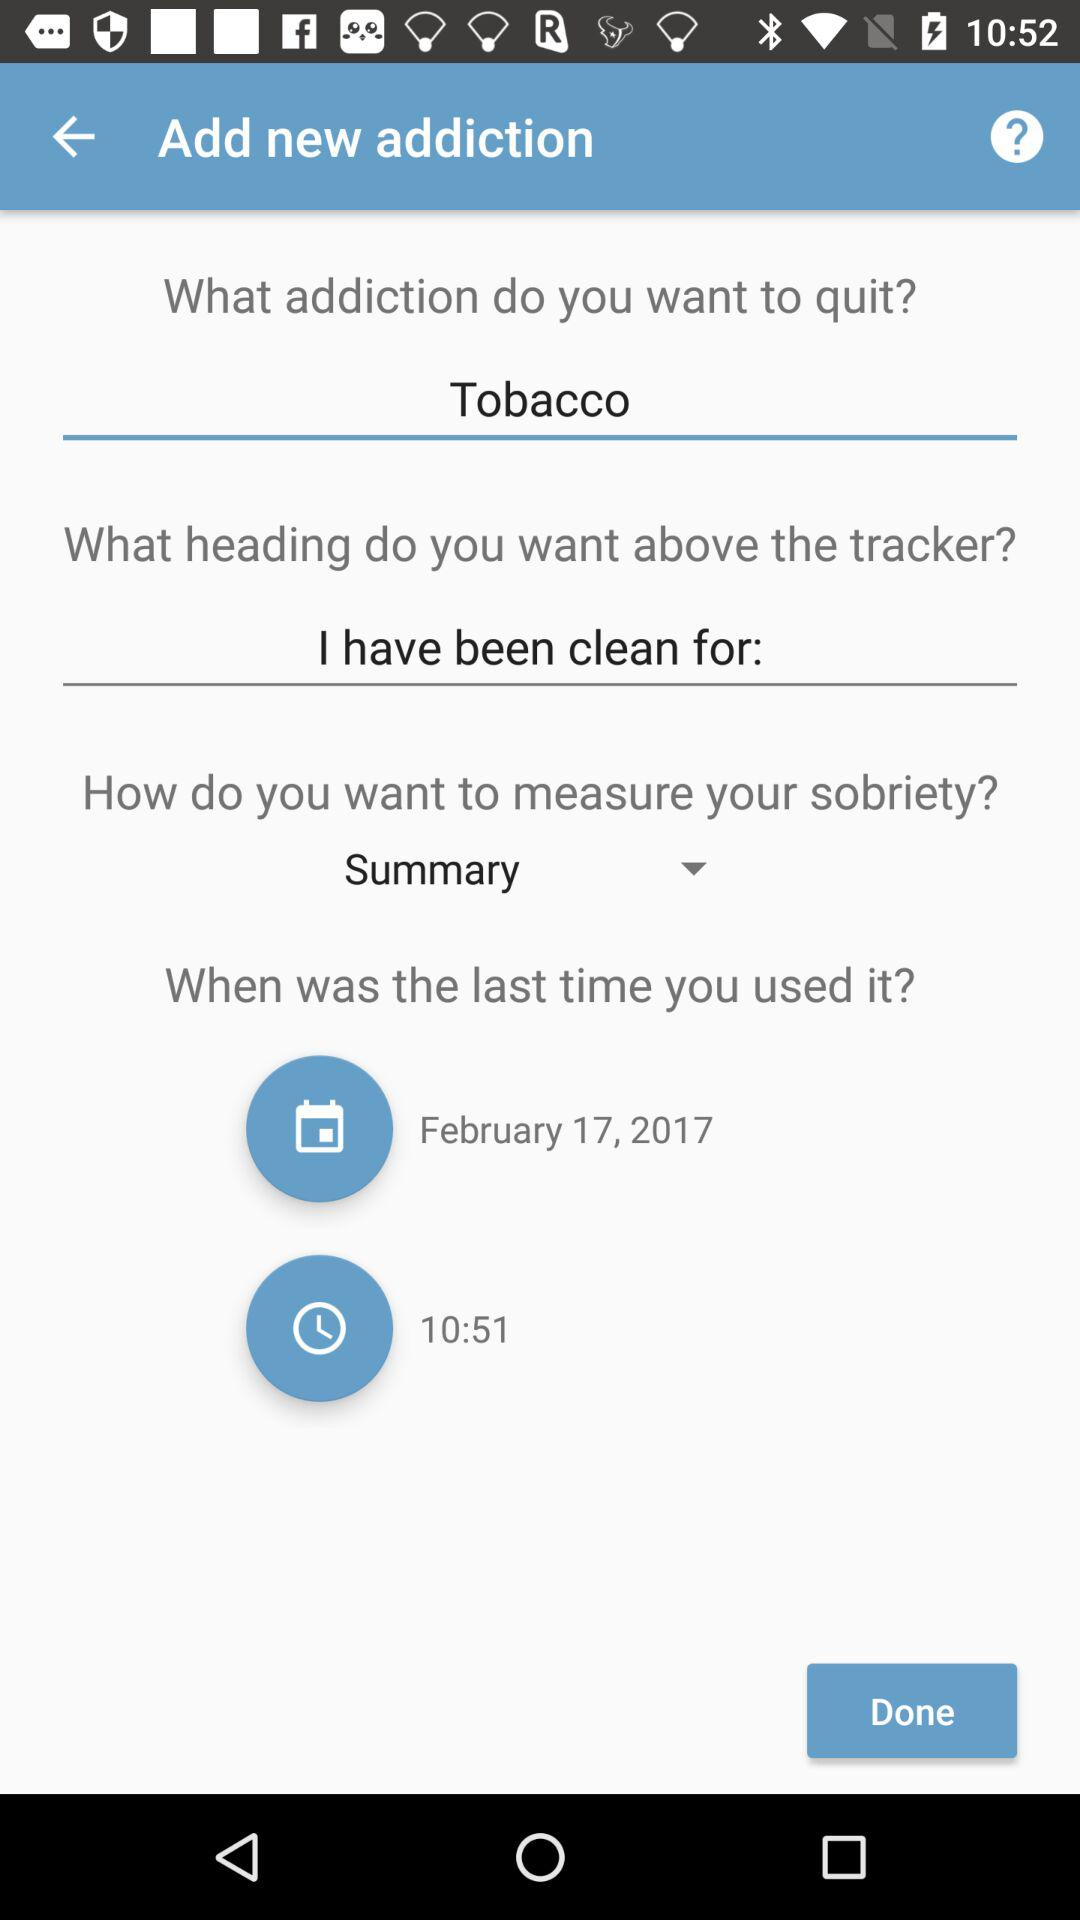What is the date? The date is February 17, 2017. 